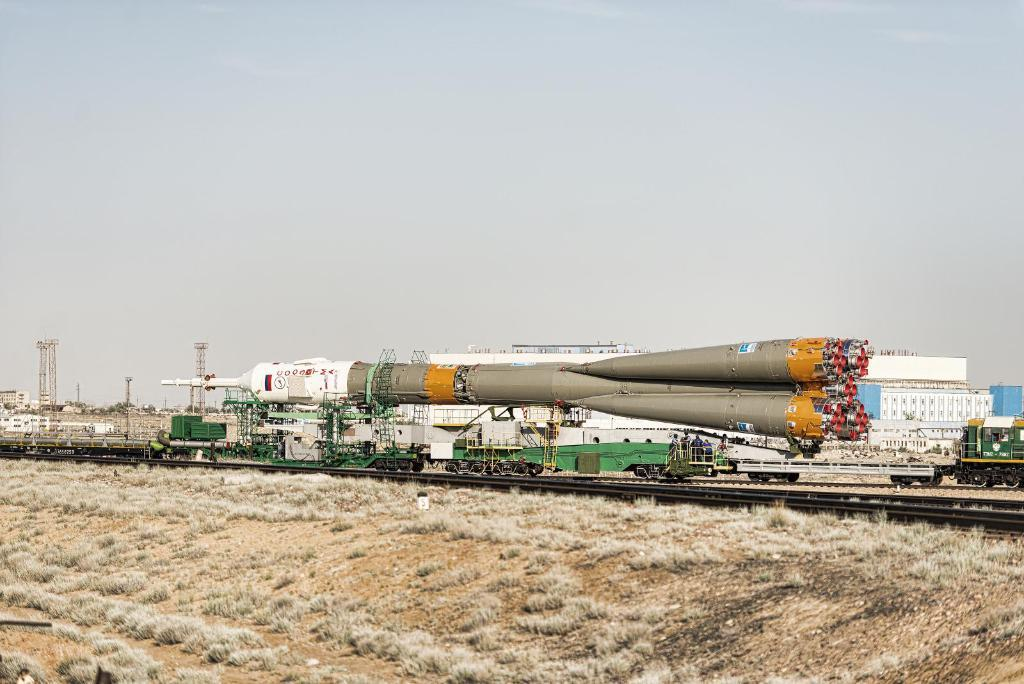What type of structures can be seen in the image? There are buildings and towers in the image. What is the purpose of the satellite in the image? The purpose of the satellite in the image is not specified, but it is likely for communication or observation purposes. What are the poles in the image used for? The poles in the image are likely used for supporting wires or other infrastructure. What type of vehicles can be seen in the image? There are vehicles in the image, but their specific types are not mentioned. What is visible at the top of the image? The sky is visible at the top of the image. What type of vegetation is present at the bottom of the image? Dry grass is present at the bottom of the image. How many pies are being delivered by the vehicles in the image? There is no mention of pies or delivery in the image, so it is not possible to answer this question. What letter is written on the side of the buildings in the image? There is no mention of letters or writing on the buildings in the image, so it is not possible to answer this question. 